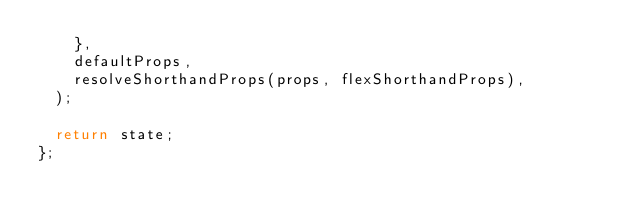<code> <loc_0><loc_0><loc_500><loc_500><_TypeScript_>    },
    defaultProps,
    resolveShorthandProps(props, flexShorthandProps),
  );

  return state;
};
</code> 